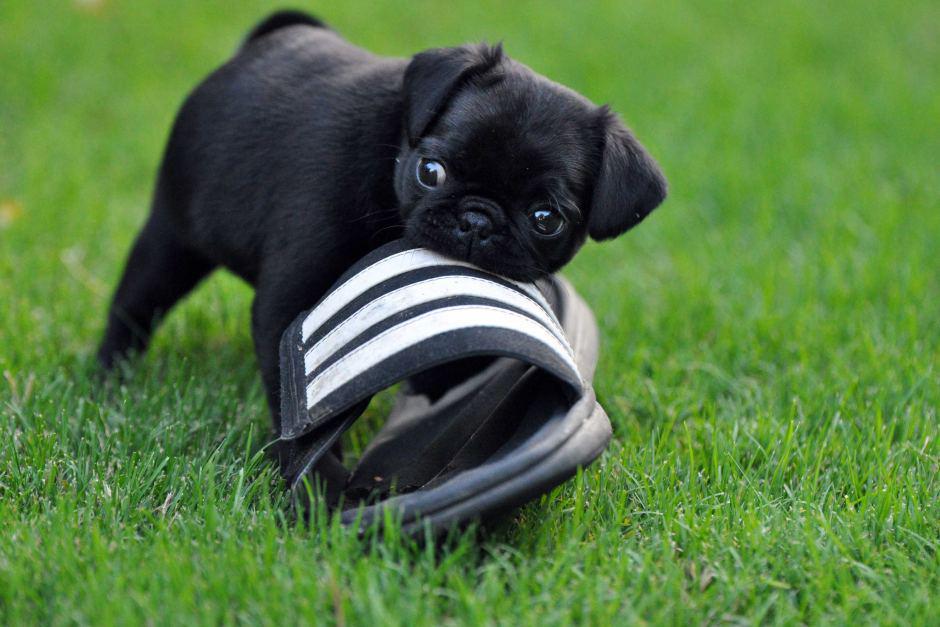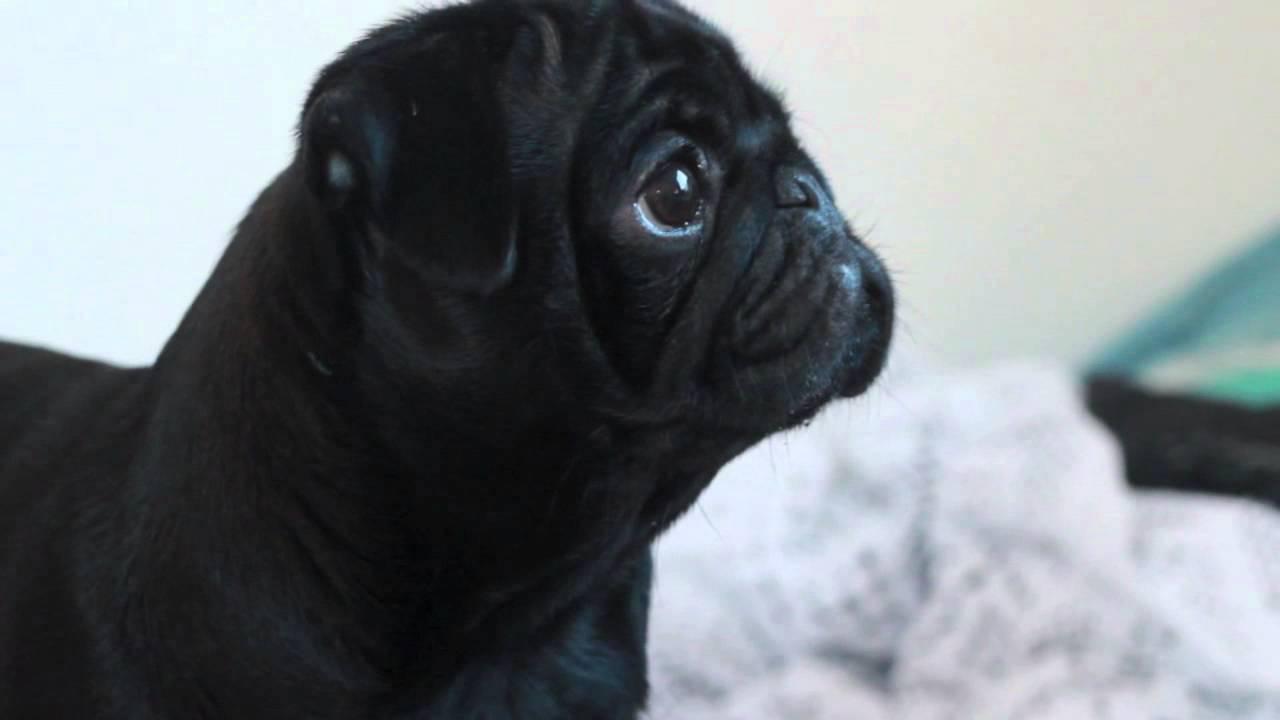The first image is the image on the left, the second image is the image on the right. Examine the images to the left and right. Is the description "The left image includes at least one black pug with something black-and-white grasped in its mouth." accurate? Answer yes or no. Yes. The first image is the image on the left, the second image is the image on the right. Evaluate the accuracy of this statement regarding the images: "The left image contains at least one pug dog outside on grass chewing on an item.". Is it true? Answer yes or no. Yes. 